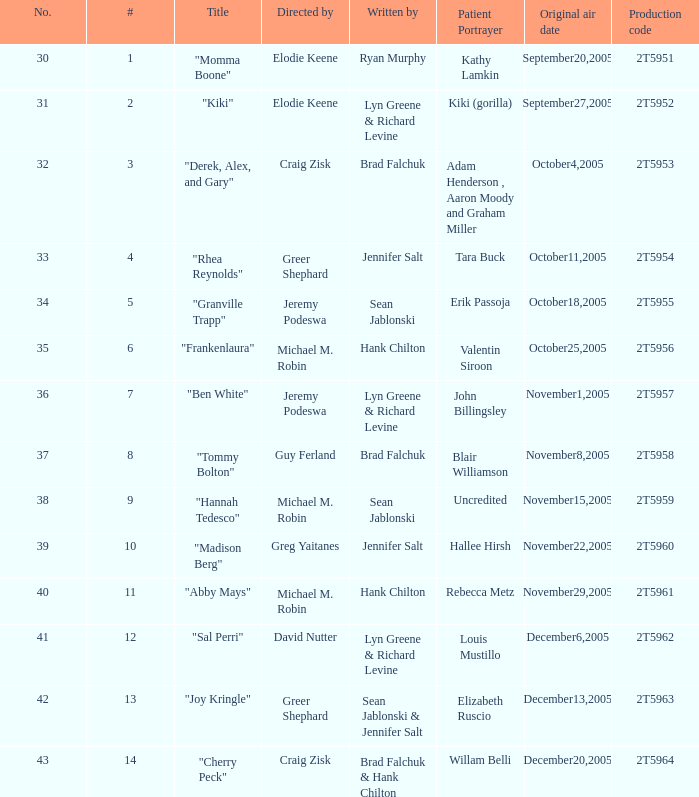What is the production code for the episode where the patient portrayer is Kathy Lamkin? 2T5951. 